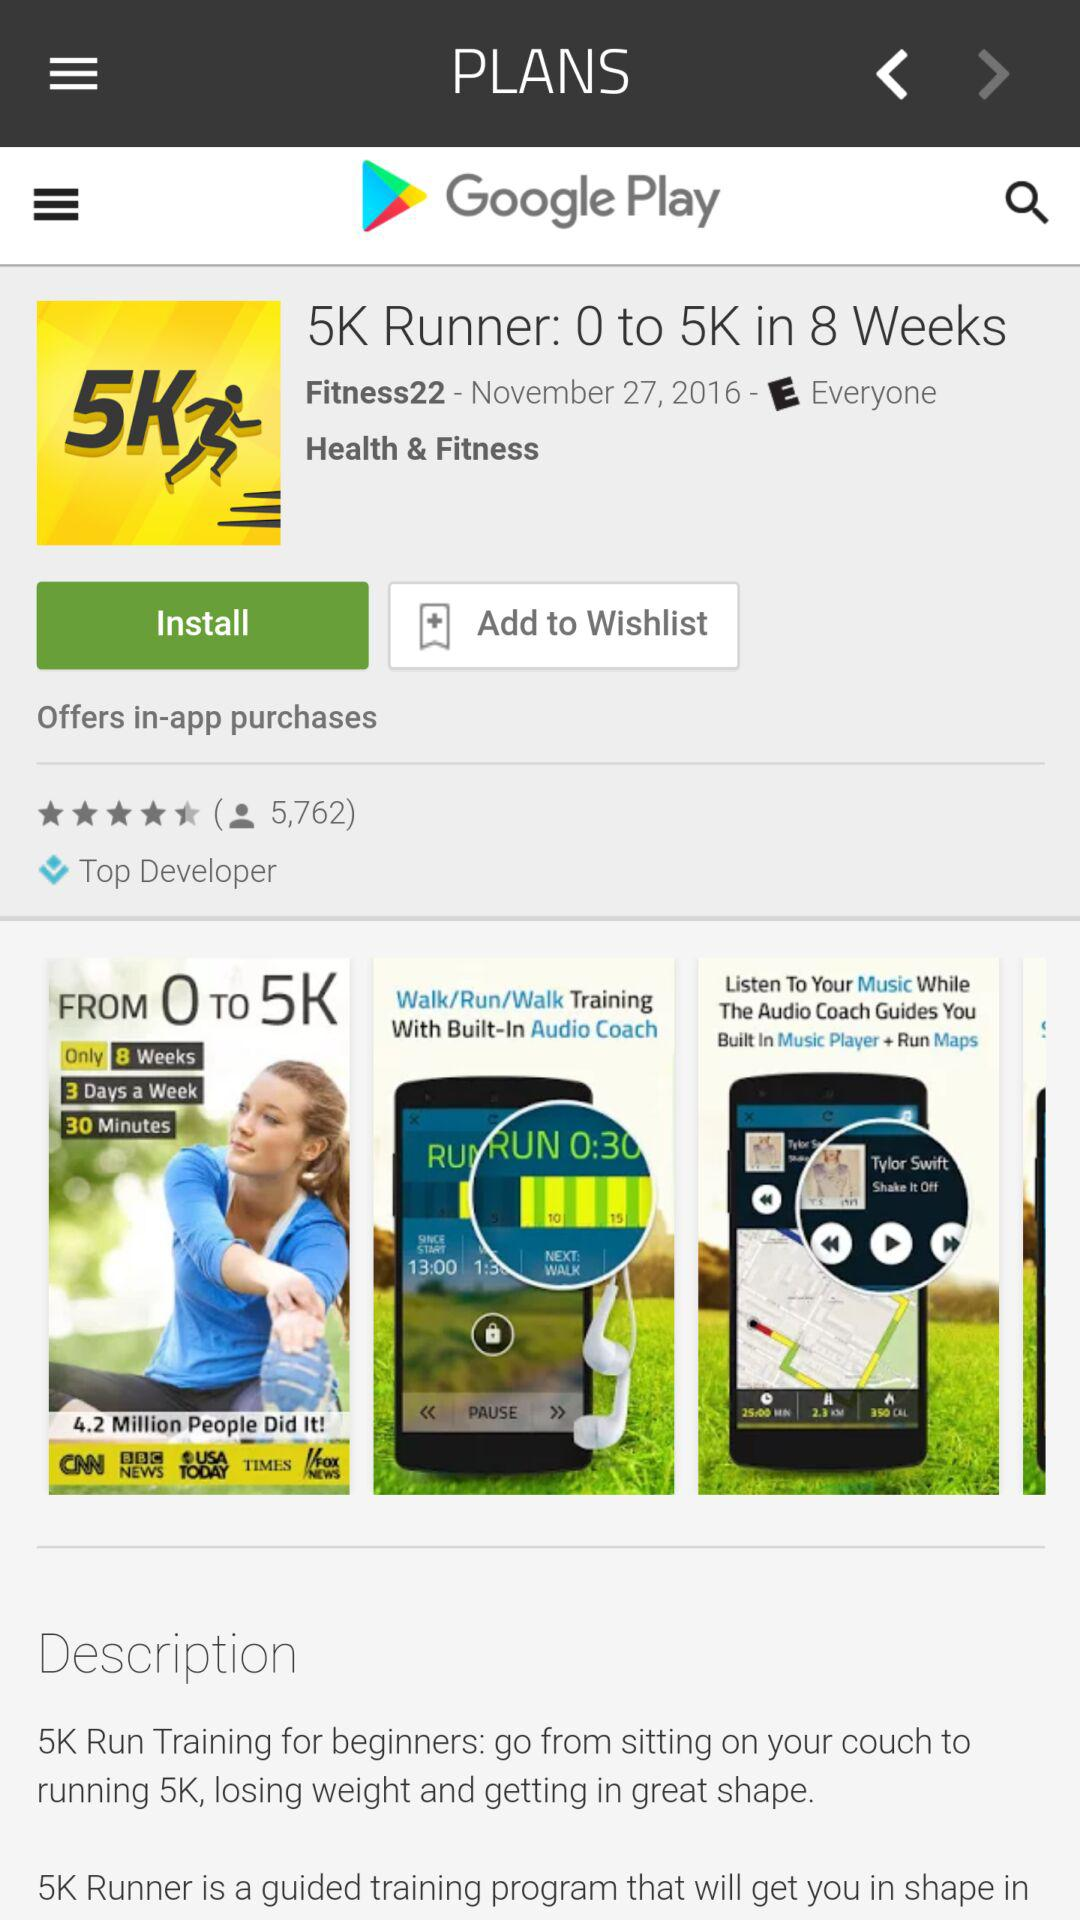How many reviews does this app have?
Answer the question using a single word or phrase. 5,762 